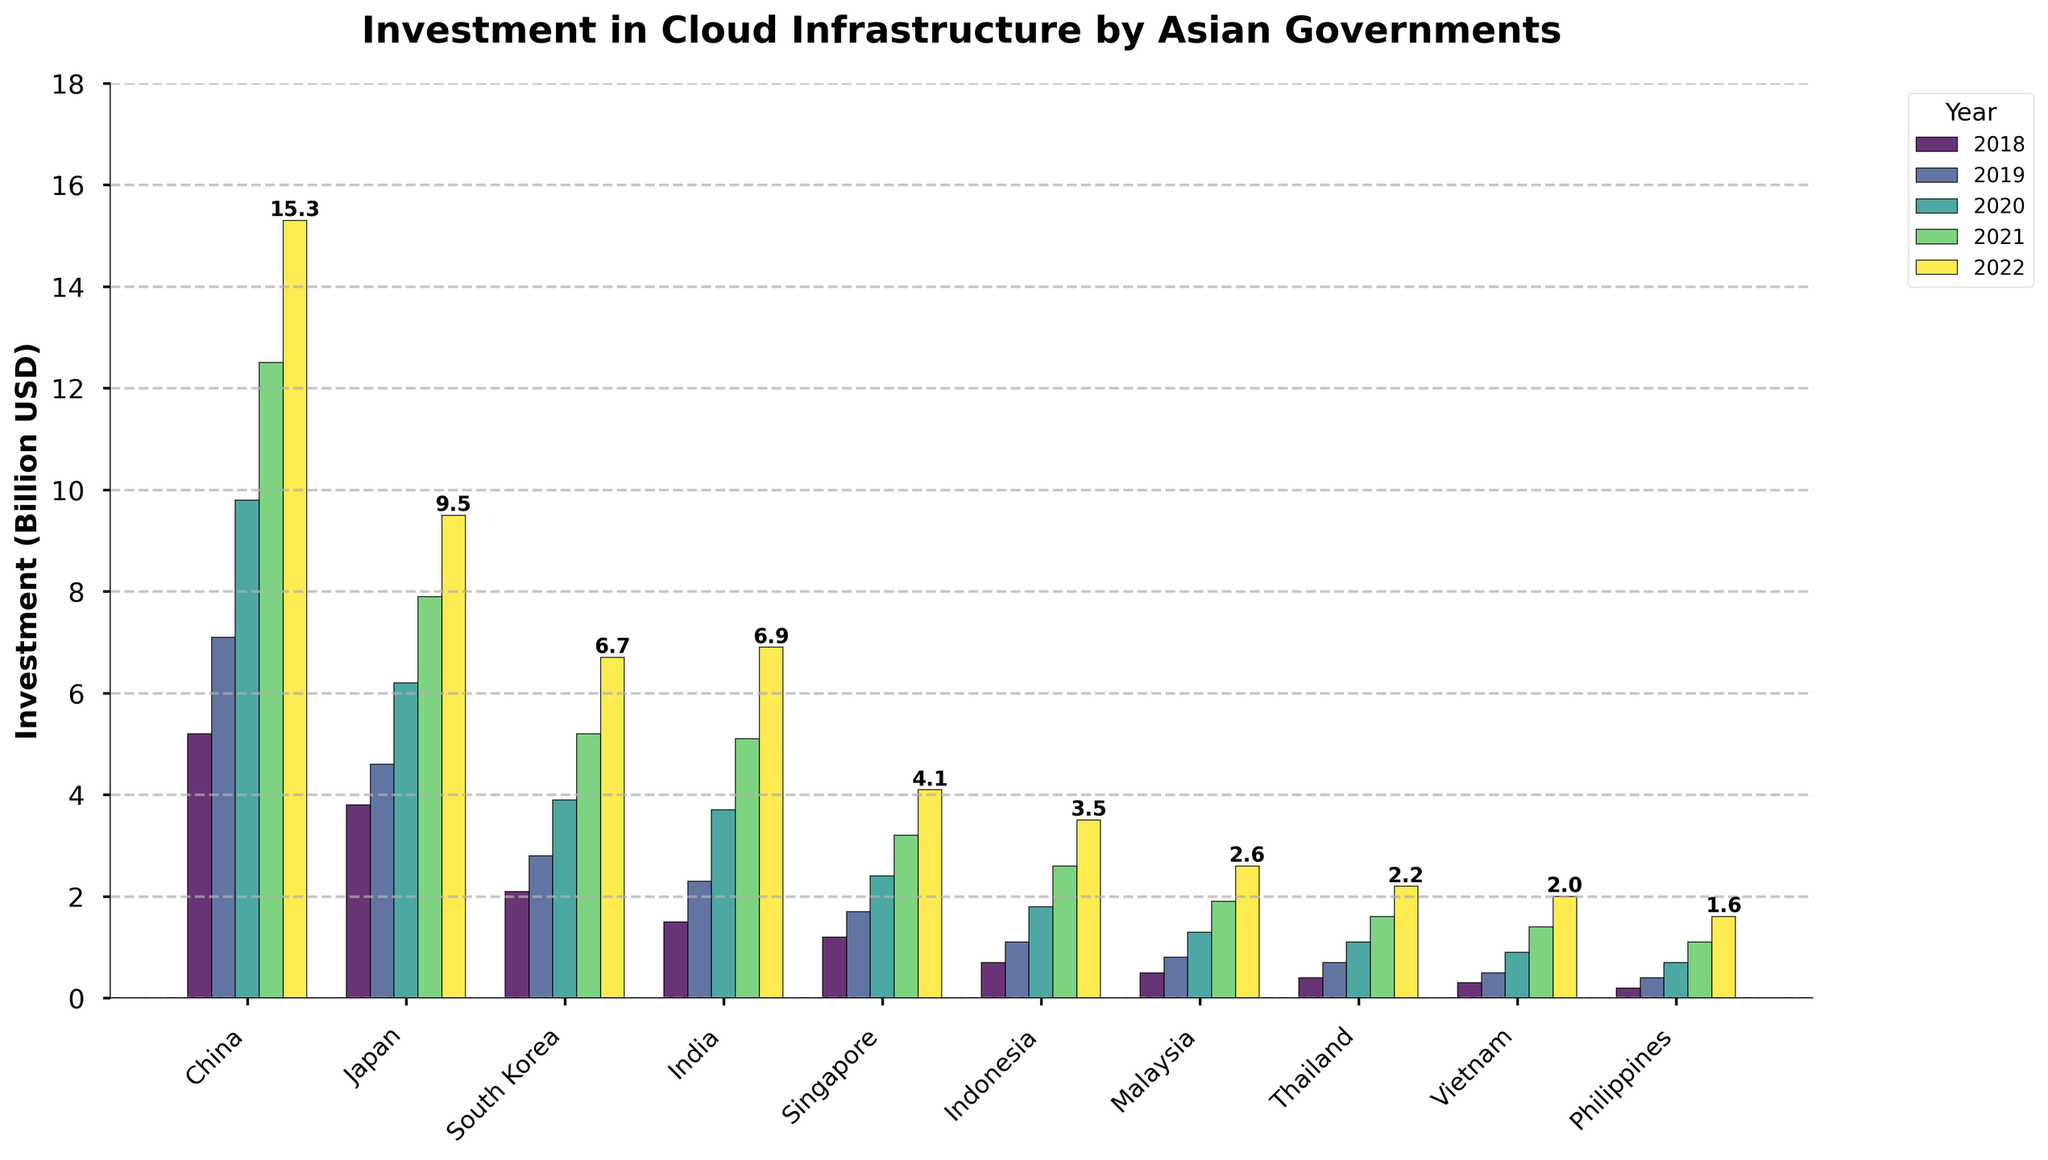What was the total investment by China and Japan in 2022? To find the total investment, sum the investments by China and Japan in 2022. China's investment is 15.3 billion USD, and Japan's investment is 9.5 billion USD. Therefore, 15.3 + 9.5 = 24.8 billion USD
Answer: 24.8 billion USD Which country had the lowest investment in 2022, and what was the amount? Look for the shortest bar in the year 2022. The shortest bar corresponds to the Philippines, with an investment amount of 1.6 billion USD
Answer: Philippines, 1.6 billion USD How much more did South Korea invest in 2021 compared to 2018? Subtract South Korea's investment in 2018 from its investment in 2021. South Korea's investment in 2021 was 5.2 billion USD and in 2018 was 2.1 billion USD. Therefore, 5.2 - 2.1 = 3.1 billion USD
Answer: 3.1 billion USD Which year showed the highest overall investment across all countries? Sum the total investments for all countries for each year and compare the sums. The year with the highest sum is 2022. Each country’s 2022 investment sums to a higher amount compared to previous years
Answer: 2022 By how much did the investment by India increase from 2019 to 2022? Subtract India's investment in 2019 from its investment in 2022. India's investment in 2022 was 6.9 billion USD and in 2019 was 2.3 billion USD. Therefore, 6.9 - 2.3 = 4.6 billion USD
Answer: 4.6 billion USD Compare the investments of Indonesia and Malaysia in 2020. Which country invested more? Look at the height of the bars for Indonesia and Malaysia in 2020. Indonesia's investment in 2020 was 1.8 billion USD, and Malaysia's was 1.3 billion USD. Indonesia invested more than Malaysia
Answer: Indonesia Which country had the highest increase in investment from 2018 to 2022? Calculate the increase in investment for each country from 2018 to 2022 by subtracting the 2018 value from the 2022 value. China had the highest increase, as 15.3 - 5.2 = 10.1 billion USD, which is higher than the increases for other countries
Answer: China What is the difference between the combined investments of Japan and South Korea in 2020 and 2021? Combine the investments for Japan and South Korea in 2020 and 2021, and then find the difference. For 2020, Japan and South Korea invested 6.2 + 3.9 = 10.1 billion USD. For 2021, they invested 7.9 + 5.2 = 13.1 billion USD. Therefore, 13.1 - 10.1 = 3 billion USD
Answer: 3 billion USD In which year did Vietnam see its investment double compared to the previous year? Identify the year in which the height of Vietnam's bar approximately doubles that of the previous year. Vietnam's investment doubled from 2019 (0.5 billion USD) to 2020 (0.9 billion USD), as 0.5 * 2 ≈ 0.9 billion
Answer: 2020 Which country's investment crossed the 10 billion USD mark first and in which year? Identify the country whose investment bar first reached above 10 billion USD and note the year. China's investment crossed the 10 billion USD mark first in the year 2020
Answer: China, 2020 